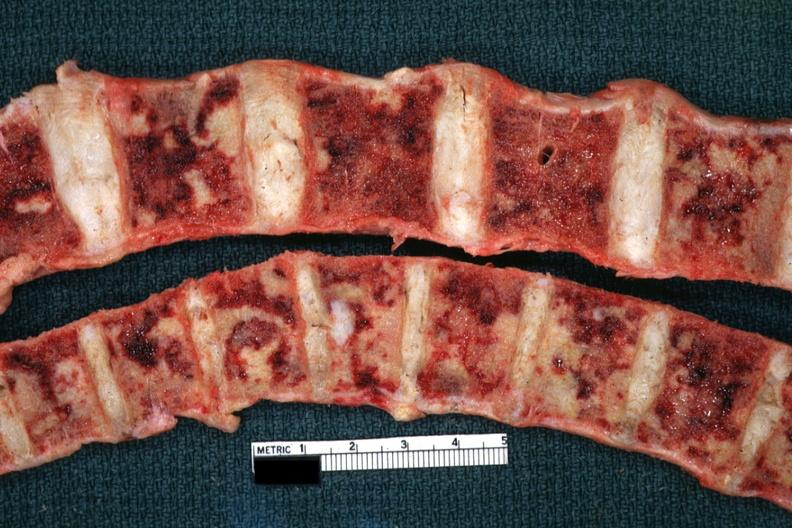what does this image show?
Answer the question using a single word or phrase. Multiple metastatic appearing lesions diagnosed reticulum cell sarcoma 